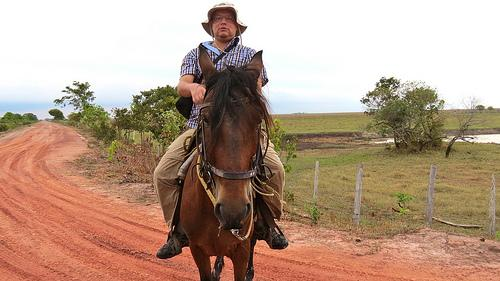Mention the key elements in the photograph and how they relate to each other. The image features a man on a brown horse riding down a clay-colored dirt road, bordered by trees, a wooden fence, and green grass, with a cloudy sky in the background. Write a brief description of the main character in the image and their surrounding environment. A man in a hat, blue plaid shirt, and brown pants rides a brown horse with black hair, traveling down a dirt road surrounded by trees, a wooden fence, and a partly cloudy sky. Mention some distinguishing features of the person on the horse in the image. The man riding the horse is wearing a hat, blue plaid shirt, brown pants, and dark brown shoes; he is also accompanied by a sack on his shoulders. Summarize the scene portrayed in the image in one sentence. A man wearing a hat and blue plaid shirt rides a brown horse along a clay dirt road, surrounded by trees and a wooden fence. Using descriptive adjectives, describe the horse and its rider in the image. A man with a light hat, blue plaid shirt, and brown pants rides a sturdy brown horse with black hair and a bridle of reins, against a natural backdrop of trees and grass. Narrate the key aspects of the image as if describing it to someone who cannot see it. In the image, a man wearing a hat, blue plaid shirt, and brown pants is riding a brown horse with black hair along a dirt road, surrounded by trees, a wooden fence, a small pond, and a cloudy sky in the background. Describe the attire of the person in the photograph and their mode of transportation. The man in the photograph wears a lightweight hat, blue plaid shirt, and khaki pants, and is riding a brown horse equipped with a bridle and reins. In a few words, describe the overall atmosphere of the location in the image. The image depicts a tranquil, rural scene with a man riding a horse on a dirt road, surrounded by lush greenery, fence posts, and a cloudy sky. Describe the pathway on which the man and the horse are located in the image. The man and the horse are on a clay-colored dirt road surrounded by trees, green grass, and a wooden fence with poles. Talk about the various natural elements present in the image. The image has trees in various sizes, green grass, a small body of water, and a white, cloudy sky in the background. 